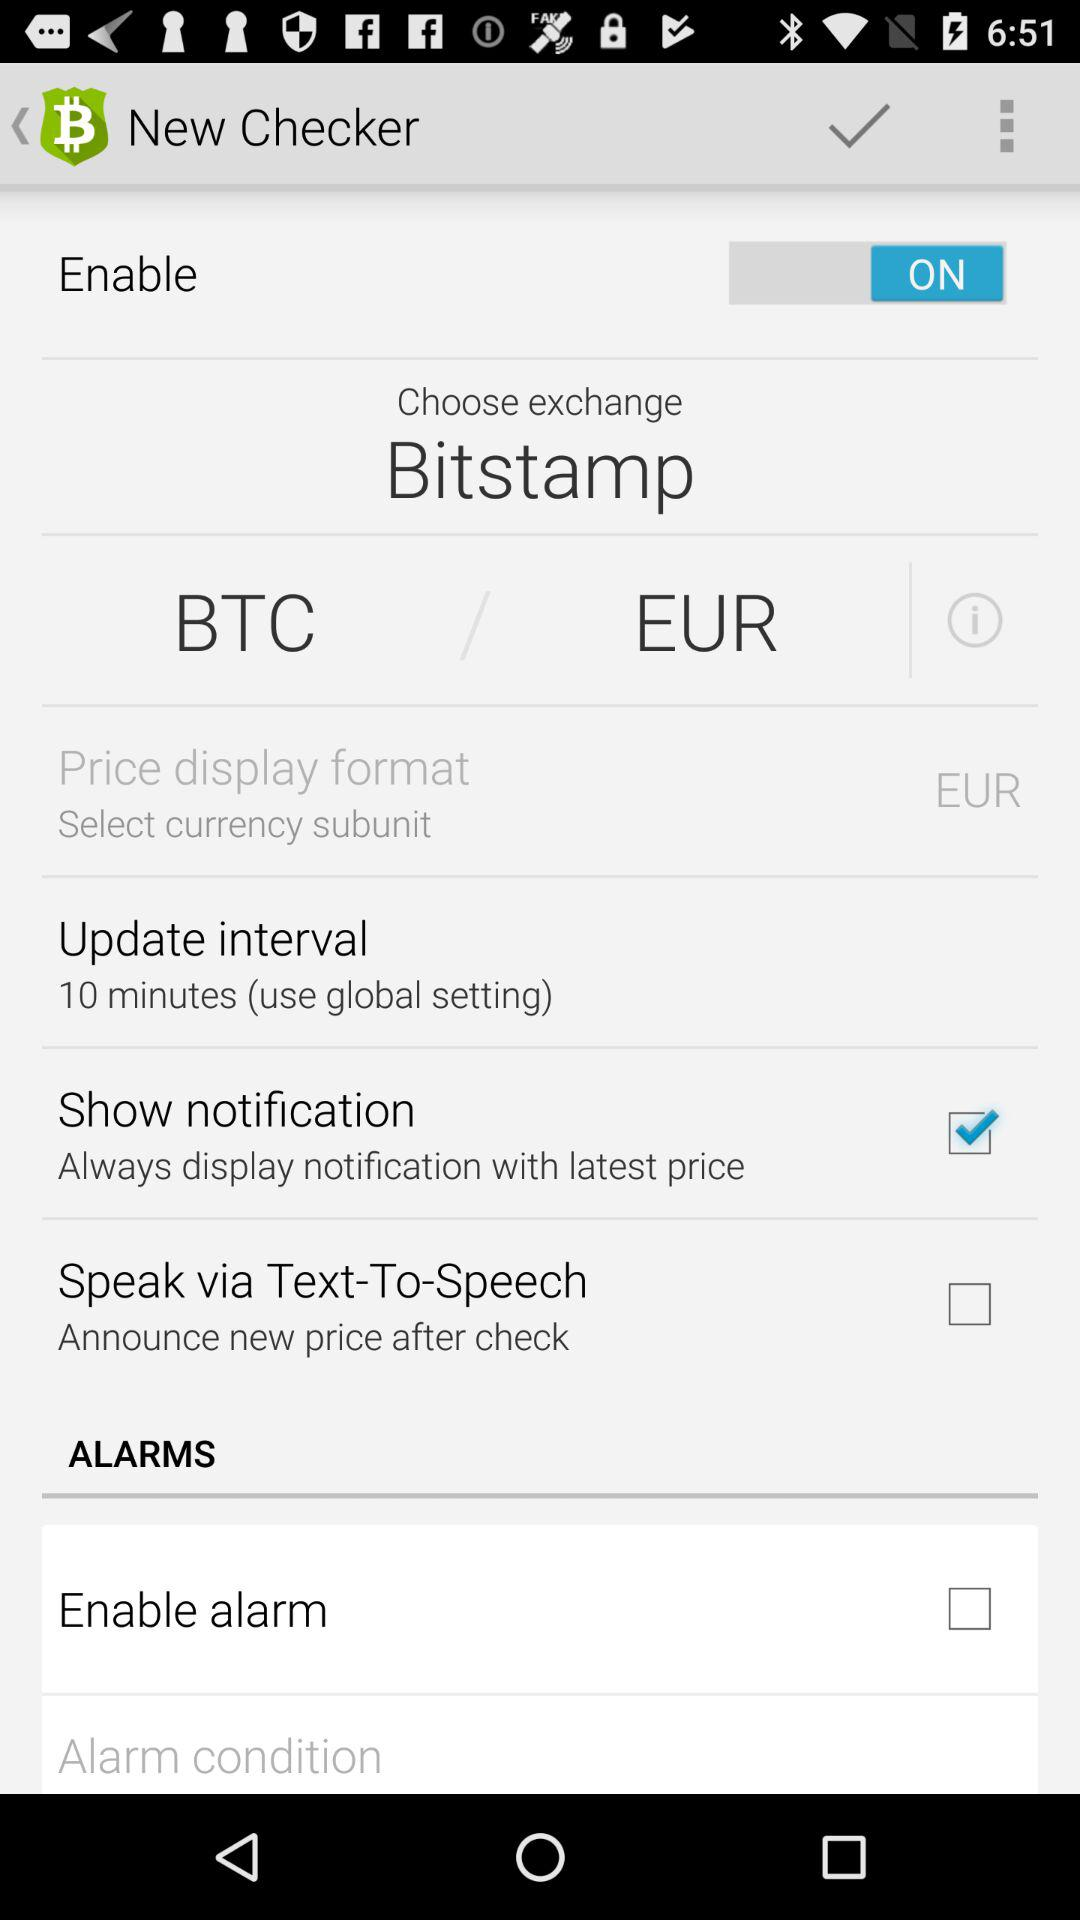How many more check boxes are there for enabling alarms than for showing notifications?
Answer the question using a single word or phrase. 1 